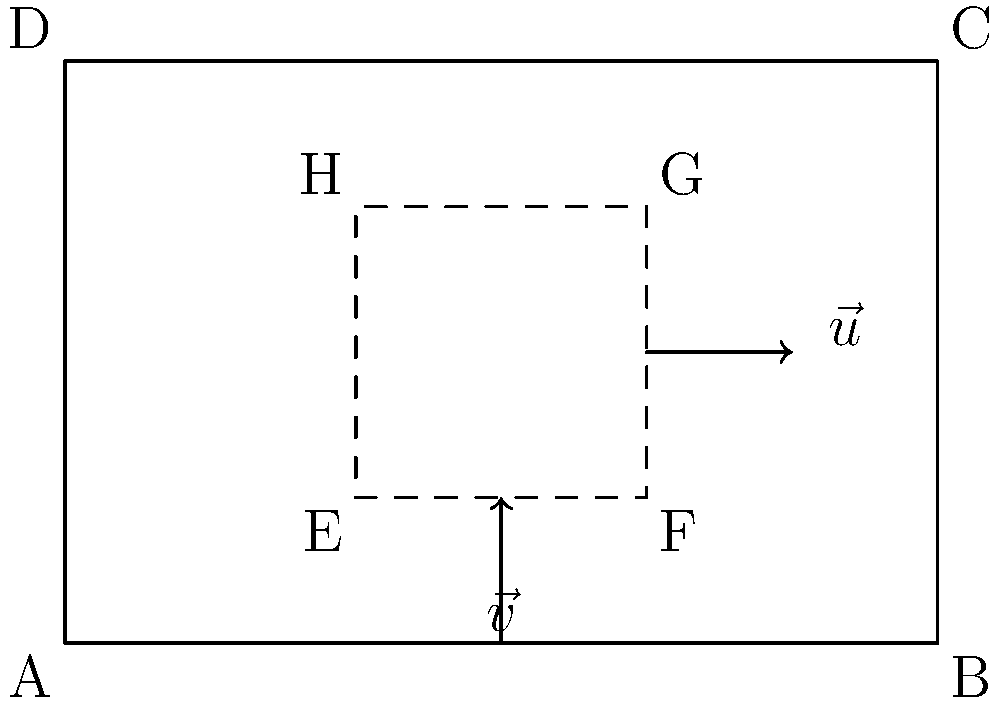In an effort to optimize the layout of a new animal shelter in Dhaka, you're analyzing the space efficiency using vector operations. The shelter is represented by rectangle ABCD, with an internal space EFGH for animal enclosures. Vector $\vec{v}$ represents the height of the enclosures, and $\vec{u}$ represents their width. If $\vec{v} = 2\hat{j}$ and $\vec{u} = 3\hat{i}$, calculate the cross product $\vec{v} \times \vec{u}$ to determine the area of each enclosure. How does this area compare to the total shelter area, and what percentage of the shelter space is utilized for animal housing? Let's approach this step-by-step:

1) First, we calculate the cross product $\vec{v} \times \vec{u}$:
   $\vec{v} \times \vec{u} = (2\hat{j}) \times (3\hat{i}) = 6(\hat{j} \times \hat{i}) = 6\hat{k}$

2) The magnitude of this cross product gives us the area of each enclosure:
   Area of enclosure = $|\vec{v} \times \vec{u}| = 6$ square units

3) Now, let's calculate the total shelter area:
   Shelter dimensions: 6 units × 4 units = 24 square units

4) The number of enclosures in the shelter:
   2 rows × 2 columns = 4 enclosures

5) Total area used for enclosures:
   4 × 6 = 24 square units

6) Percentage of shelter space utilized for animal housing:
   $(24 / 24) \times 100\% = 100\%$

Therefore, the area of each enclosure is 6 square units, which is exactly 1/4 of the total shelter area. The layout utilizes 100% of the available space for animal housing, maximizing efficiency.
Answer: 6 square units per enclosure; 100% space utilization 